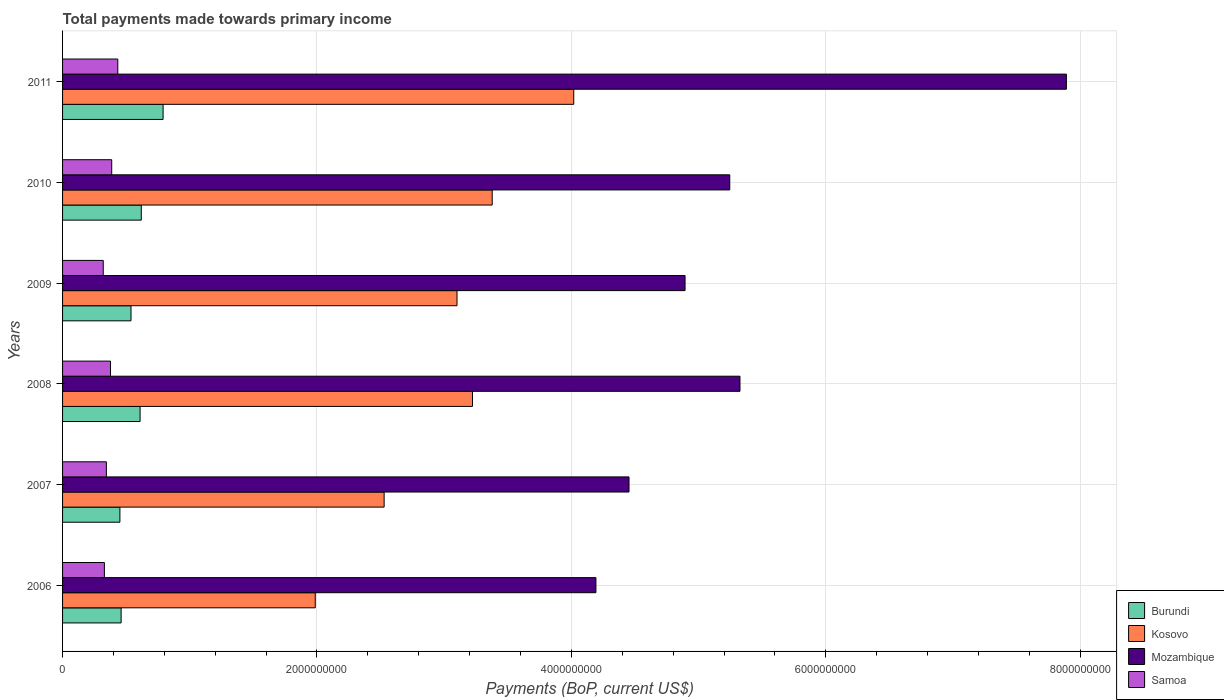How many different coloured bars are there?
Your response must be concise. 4. How many bars are there on the 2nd tick from the top?
Keep it short and to the point. 4. How many bars are there on the 6th tick from the bottom?
Offer a very short reply. 4. What is the total payments made towards primary income in Kosovo in 2009?
Your response must be concise. 3.10e+09. Across all years, what is the maximum total payments made towards primary income in Mozambique?
Provide a succinct answer. 7.89e+09. Across all years, what is the minimum total payments made towards primary income in Burundi?
Your answer should be very brief. 4.51e+08. In which year was the total payments made towards primary income in Samoa maximum?
Ensure brevity in your answer.  2011. What is the total total payments made towards primary income in Mozambique in the graph?
Offer a terse response. 3.20e+1. What is the difference between the total payments made towards primary income in Samoa in 2009 and that in 2011?
Provide a short and direct response. -1.14e+08. What is the difference between the total payments made towards primary income in Kosovo in 2006 and the total payments made towards primary income in Samoa in 2007?
Make the answer very short. 1.64e+09. What is the average total payments made towards primary income in Burundi per year?
Provide a succinct answer. 5.78e+08. In the year 2010, what is the difference between the total payments made towards primary income in Samoa and total payments made towards primary income in Burundi?
Provide a succinct answer. -2.32e+08. What is the ratio of the total payments made towards primary income in Mozambique in 2006 to that in 2011?
Give a very brief answer. 0.53. Is the total payments made towards primary income in Kosovo in 2006 less than that in 2011?
Keep it short and to the point. Yes. What is the difference between the highest and the second highest total payments made towards primary income in Samoa?
Your answer should be compact. 4.78e+07. What is the difference between the highest and the lowest total payments made towards primary income in Kosovo?
Your response must be concise. 2.03e+09. In how many years, is the total payments made towards primary income in Burundi greater than the average total payments made towards primary income in Burundi taken over all years?
Your response must be concise. 3. Is the sum of the total payments made towards primary income in Mozambique in 2007 and 2009 greater than the maximum total payments made towards primary income in Samoa across all years?
Your answer should be very brief. Yes. Is it the case that in every year, the sum of the total payments made towards primary income in Samoa and total payments made towards primary income in Burundi is greater than the sum of total payments made towards primary income in Mozambique and total payments made towards primary income in Kosovo?
Your answer should be compact. No. What does the 1st bar from the top in 2006 represents?
Make the answer very short. Samoa. What does the 3rd bar from the bottom in 2010 represents?
Offer a terse response. Mozambique. Are the values on the major ticks of X-axis written in scientific E-notation?
Provide a short and direct response. No. Where does the legend appear in the graph?
Ensure brevity in your answer.  Bottom right. How are the legend labels stacked?
Your response must be concise. Vertical. What is the title of the graph?
Your response must be concise. Total payments made towards primary income. What is the label or title of the X-axis?
Your response must be concise. Payments (BoP, current US$). What is the Payments (BoP, current US$) in Burundi in 2006?
Make the answer very short. 4.60e+08. What is the Payments (BoP, current US$) of Kosovo in 2006?
Your answer should be compact. 1.99e+09. What is the Payments (BoP, current US$) in Mozambique in 2006?
Make the answer very short. 4.19e+09. What is the Payments (BoP, current US$) in Samoa in 2006?
Offer a very short reply. 3.29e+08. What is the Payments (BoP, current US$) of Burundi in 2007?
Offer a terse response. 4.51e+08. What is the Payments (BoP, current US$) in Kosovo in 2007?
Offer a very short reply. 2.53e+09. What is the Payments (BoP, current US$) in Mozambique in 2007?
Your answer should be compact. 4.45e+09. What is the Payments (BoP, current US$) of Samoa in 2007?
Make the answer very short. 3.44e+08. What is the Payments (BoP, current US$) of Burundi in 2008?
Provide a short and direct response. 6.09e+08. What is the Payments (BoP, current US$) of Kosovo in 2008?
Make the answer very short. 3.22e+09. What is the Payments (BoP, current US$) in Mozambique in 2008?
Keep it short and to the point. 5.33e+09. What is the Payments (BoP, current US$) in Samoa in 2008?
Make the answer very short. 3.77e+08. What is the Payments (BoP, current US$) in Burundi in 2009?
Your answer should be very brief. 5.38e+08. What is the Payments (BoP, current US$) in Kosovo in 2009?
Provide a succinct answer. 3.10e+09. What is the Payments (BoP, current US$) in Mozambique in 2009?
Provide a succinct answer. 4.89e+09. What is the Payments (BoP, current US$) of Samoa in 2009?
Keep it short and to the point. 3.20e+08. What is the Payments (BoP, current US$) of Burundi in 2010?
Make the answer very short. 6.19e+08. What is the Payments (BoP, current US$) in Kosovo in 2010?
Provide a short and direct response. 3.38e+09. What is the Payments (BoP, current US$) in Mozambique in 2010?
Ensure brevity in your answer.  5.24e+09. What is the Payments (BoP, current US$) in Samoa in 2010?
Offer a terse response. 3.86e+08. What is the Payments (BoP, current US$) of Burundi in 2011?
Your answer should be very brief. 7.90e+08. What is the Payments (BoP, current US$) in Kosovo in 2011?
Ensure brevity in your answer.  4.02e+09. What is the Payments (BoP, current US$) of Mozambique in 2011?
Your response must be concise. 7.89e+09. What is the Payments (BoP, current US$) of Samoa in 2011?
Your response must be concise. 4.34e+08. Across all years, what is the maximum Payments (BoP, current US$) in Burundi?
Provide a short and direct response. 7.90e+08. Across all years, what is the maximum Payments (BoP, current US$) of Kosovo?
Provide a short and direct response. 4.02e+09. Across all years, what is the maximum Payments (BoP, current US$) in Mozambique?
Make the answer very short. 7.89e+09. Across all years, what is the maximum Payments (BoP, current US$) of Samoa?
Your answer should be compact. 4.34e+08. Across all years, what is the minimum Payments (BoP, current US$) of Burundi?
Keep it short and to the point. 4.51e+08. Across all years, what is the minimum Payments (BoP, current US$) in Kosovo?
Ensure brevity in your answer.  1.99e+09. Across all years, what is the minimum Payments (BoP, current US$) in Mozambique?
Make the answer very short. 4.19e+09. Across all years, what is the minimum Payments (BoP, current US$) in Samoa?
Make the answer very short. 3.20e+08. What is the total Payments (BoP, current US$) of Burundi in the graph?
Offer a very short reply. 3.47e+09. What is the total Payments (BoP, current US$) in Kosovo in the graph?
Ensure brevity in your answer.  1.82e+1. What is the total Payments (BoP, current US$) of Mozambique in the graph?
Ensure brevity in your answer.  3.20e+1. What is the total Payments (BoP, current US$) in Samoa in the graph?
Your answer should be compact. 2.19e+09. What is the difference between the Payments (BoP, current US$) in Burundi in 2006 and that in 2007?
Offer a terse response. 9.56e+06. What is the difference between the Payments (BoP, current US$) of Kosovo in 2006 and that in 2007?
Your response must be concise. -5.41e+08. What is the difference between the Payments (BoP, current US$) in Mozambique in 2006 and that in 2007?
Offer a very short reply. -2.60e+08. What is the difference between the Payments (BoP, current US$) of Samoa in 2006 and that in 2007?
Keep it short and to the point. -1.56e+07. What is the difference between the Payments (BoP, current US$) in Burundi in 2006 and that in 2008?
Your response must be concise. -1.49e+08. What is the difference between the Payments (BoP, current US$) in Kosovo in 2006 and that in 2008?
Your response must be concise. -1.24e+09. What is the difference between the Payments (BoP, current US$) of Mozambique in 2006 and that in 2008?
Your response must be concise. -1.13e+09. What is the difference between the Payments (BoP, current US$) of Samoa in 2006 and that in 2008?
Offer a terse response. -4.81e+07. What is the difference between the Payments (BoP, current US$) in Burundi in 2006 and that in 2009?
Keep it short and to the point. -7.76e+07. What is the difference between the Payments (BoP, current US$) in Kosovo in 2006 and that in 2009?
Make the answer very short. -1.11e+09. What is the difference between the Payments (BoP, current US$) in Mozambique in 2006 and that in 2009?
Your answer should be very brief. -7.01e+08. What is the difference between the Payments (BoP, current US$) of Samoa in 2006 and that in 2009?
Offer a terse response. 8.97e+06. What is the difference between the Payments (BoP, current US$) of Burundi in 2006 and that in 2010?
Make the answer very short. -1.58e+08. What is the difference between the Payments (BoP, current US$) of Kosovo in 2006 and that in 2010?
Your response must be concise. -1.39e+09. What is the difference between the Payments (BoP, current US$) in Mozambique in 2006 and that in 2010?
Offer a very short reply. -1.05e+09. What is the difference between the Payments (BoP, current US$) in Samoa in 2006 and that in 2010?
Give a very brief answer. -5.76e+07. What is the difference between the Payments (BoP, current US$) in Burundi in 2006 and that in 2011?
Make the answer very short. -3.30e+08. What is the difference between the Payments (BoP, current US$) in Kosovo in 2006 and that in 2011?
Provide a succinct answer. -2.03e+09. What is the difference between the Payments (BoP, current US$) in Mozambique in 2006 and that in 2011?
Offer a terse response. -3.70e+09. What is the difference between the Payments (BoP, current US$) of Samoa in 2006 and that in 2011?
Your answer should be compact. -1.05e+08. What is the difference between the Payments (BoP, current US$) of Burundi in 2007 and that in 2008?
Offer a terse response. -1.59e+08. What is the difference between the Payments (BoP, current US$) in Kosovo in 2007 and that in 2008?
Offer a very short reply. -6.94e+08. What is the difference between the Payments (BoP, current US$) of Mozambique in 2007 and that in 2008?
Offer a terse response. -8.72e+08. What is the difference between the Payments (BoP, current US$) of Samoa in 2007 and that in 2008?
Your answer should be compact. -3.25e+07. What is the difference between the Payments (BoP, current US$) in Burundi in 2007 and that in 2009?
Provide a succinct answer. -8.72e+07. What is the difference between the Payments (BoP, current US$) of Kosovo in 2007 and that in 2009?
Your answer should be very brief. -5.73e+08. What is the difference between the Payments (BoP, current US$) of Mozambique in 2007 and that in 2009?
Keep it short and to the point. -4.41e+08. What is the difference between the Payments (BoP, current US$) in Samoa in 2007 and that in 2009?
Provide a succinct answer. 2.46e+07. What is the difference between the Payments (BoP, current US$) in Burundi in 2007 and that in 2010?
Your response must be concise. -1.68e+08. What is the difference between the Payments (BoP, current US$) of Kosovo in 2007 and that in 2010?
Make the answer very short. -8.50e+08. What is the difference between the Payments (BoP, current US$) of Mozambique in 2007 and that in 2010?
Your answer should be very brief. -7.92e+08. What is the difference between the Payments (BoP, current US$) of Samoa in 2007 and that in 2010?
Ensure brevity in your answer.  -4.20e+07. What is the difference between the Payments (BoP, current US$) in Burundi in 2007 and that in 2011?
Your answer should be compact. -3.39e+08. What is the difference between the Payments (BoP, current US$) of Kosovo in 2007 and that in 2011?
Your response must be concise. -1.49e+09. What is the difference between the Payments (BoP, current US$) of Mozambique in 2007 and that in 2011?
Provide a short and direct response. -3.44e+09. What is the difference between the Payments (BoP, current US$) in Samoa in 2007 and that in 2011?
Ensure brevity in your answer.  -8.98e+07. What is the difference between the Payments (BoP, current US$) of Burundi in 2008 and that in 2009?
Provide a short and direct response. 7.14e+07. What is the difference between the Payments (BoP, current US$) of Kosovo in 2008 and that in 2009?
Offer a very short reply. 1.22e+08. What is the difference between the Payments (BoP, current US$) in Mozambique in 2008 and that in 2009?
Keep it short and to the point. 4.32e+08. What is the difference between the Payments (BoP, current US$) in Samoa in 2008 and that in 2009?
Your response must be concise. 5.70e+07. What is the difference between the Payments (BoP, current US$) of Burundi in 2008 and that in 2010?
Your answer should be very brief. -9.31e+06. What is the difference between the Payments (BoP, current US$) of Kosovo in 2008 and that in 2010?
Make the answer very short. -1.55e+08. What is the difference between the Payments (BoP, current US$) in Mozambique in 2008 and that in 2010?
Provide a short and direct response. 8.03e+07. What is the difference between the Payments (BoP, current US$) of Samoa in 2008 and that in 2010?
Offer a very short reply. -9.55e+06. What is the difference between the Payments (BoP, current US$) of Burundi in 2008 and that in 2011?
Your answer should be compact. -1.81e+08. What is the difference between the Payments (BoP, current US$) in Kosovo in 2008 and that in 2011?
Ensure brevity in your answer.  -7.96e+08. What is the difference between the Payments (BoP, current US$) in Mozambique in 2008 and that in 2011?
Your response must be concise. -2.57e+09. What is the difference between the Payments (BoP, current US$) in Samoa in 2008 and that in 2011?
Your response must be concise. -5.74e+07. What is the difference between the Payments (BoP, current US$) in Burundi in 2009 and that in 2010?
Offer a very short reply. -8.07e+07. What is the difference between the Payments (BoP, current US$) of Kosovo in 2009 and that in 2010?
Provide a succinct answer. -2.77e+08. What is the difference between the Payments (BoP, current US$) in Mozambique in 2009 and that in 2010?
Make the answer very short. -3.51e+08. What is the difference between the Payments (BoP, current US$) in Samoa in 2009 and that in 2010?
Provide a succinct answer. -6.66e+07. What is the difference between the Payments (BoP, current US$) of Burundi in 2009 and that in 2011?
Your response must be concise. -2.52e+08. What is the difference between the Payments (BoP, current US$) in Kosovo in 2009 and that in 2011?
Offer a very short reply. -9.18e+08. What is the difference between the Payments (BoP, current US$) of Mozambique in 2009 and that in 2011?
Your answer should be very brief. -3.00e+09. What is the difference between the Payments (BoP, current US$) in Samoa in 2009 and that in 2011?
Your answer should be compact. -1.14e+08. What is the difference between the Payments (BoP, current US$) in Burundi in 2010 and that in 2011?
Keep it short and to the point. -1.72e+08. What is the difference between the Payments (BoP, current US$) of Kosovo in 2010 and that in 2011?
Provide a succinct answer. -6.41e+08. What is the difference between the Payments (BoP, current US$) in Mozambique in 2010 and that in 2011?
Keep it short and to the point. -2.65e+09. What is the difference between the Payments (BoP, current US$) in Samoa in 2010 and that in 2011?
Offer a terse response. -4.78e+07. What is the difference between the Payments (BoP, current US$) in Burundi in 2006 and the Payments (BoP, current US$) in Kosovo in 2007?
Ensure brevity in your answer.  -2.07e+09. What is the difference between the Payments (BoP, current US$) in Burundi in 2006 and the Payments (BoP, current US$) in Mozambique in 2007?
Your answer should be compact. -3.99e+09. What is the difference between the Payments (BoP, current US$) of Burundi in 2006 and the Payments (BoP, current US$) of Samoa in 2007?
Provide a short and direct response. 1.16e+08. What is the difference between the Payments (BoP, current US$) in Kosovo in 2006 and the Payments (BoP, current US$) in Mozambique in 2007?
Give a very brief answer. -2.47e+09. What is the difference between the Payments (BoP, current US$) of Kosovo in 2006 and the Payments (BoP, current US$) of Samoa in 2007?
Make the answer very short. 1.64e+09. What is the difference between the Payments (BoP, current US$) of Mozambique in 2006 and the Payments (BoP, current US$) of Samoa in 2007?
Provide a succinct answer. 3.85e+09. What is the difference between the Payments (BoP, current US$) of Burundi in 2006 and the Payments (BoP, current US$) of Kosovo in 2008?
Provide a succinct answer. -2.76e+09. What is the difference between the Payments (BoP, current US$) in Burundi in 2006 and the Payments (BoP, current US$) in Mozambique in 2008?
Your answer should be very brief. -4.86e+09. What is the difference between the Payments (BoP, current US$) of Burundi in 2006 and the Payments (BoP, current US$) of Samoa in 2008?
Make the answer very short. 8.35e+07. What is the difference between the Payments (BoP, current US$) in Kosovo in 2006 and the Payments (BoP, current US$) in Mozambique in 2008?
Provide a succinct answer. -3.34e+09. What is the difference between the Payments (BoP, current US$) of Kosovo in 2006 and the Payments (BoP, current US$) of Samoa in 2008?
Keep it short and to the point. 1.61e+09. What is the difference between the Payments (BoP, current US$) of Mozambique in 2006 and the Payments (BoP, current US$) of Samoa in 2008?
Give a very brief answer. 3.82e+09. What is the difference between the Payments (BoP, current US$) in Burundi in 2006 and the Payments (BoP, current US$) in Kosovo in 2009?
Provide a short and direct response. -2.64e+09. What is the difference between the Payments (BoP, current US$) in Burundi in 2006 and the Payments (BoP, current US$) in Mozambique in 2009?
Give a very brief answer. -4.43e+09. What is the difference between the Payments (BoP, current US$) in Burundi in 2006 and the Payments (BoP, current US$) in Samoa in 2009?
Make the answer very short. 1.41e+08. What is the difference between the Payments (BoP, current US$) of Kosovo in 2006 and the Payments (BoP, current US$) of Mozambique in 2009?
Give a very brief answer. -2.91e+09. What is the difference between the Payments (BoP, current US$) in Kosovo in 2006 and the Payments (BoP, current US$) in Samoa in 2009?
Your response must be concise. 1.67e+09. What is the difference between the Payments (BoP, current US$) in Mozambique in 2006 and the Payments (BoP, current US$) in Samoa in 2009?
Provide a succinct answer. 3.87e+09. What is the difference between the Payments (BoP, current US$) of Burundi in 2006 and the Payments (BoP, current US$) of Kosovo in 2010?
Provide a short and direct response. -2.92e+09. What is the difference between the Payments (BoP, current US$) in Burundi in 2006 and the Payments (BoP, current US$) in Mozambique in 2010?
Your answer should be very brief. -4.78e+09. What is the difference between the Payments (BoP, current US$) of Burundi in 2006 and the Payments (BoP, current US$) of Samoa in 2010?
Provide a short and direct response. 7.40e+07. What is the difference between the Payments (BoP, current US$) of Kosovo in 2006 and the Payments (BoP, current US$) of Mozambique in 2010?
Ensure brevity in your answer.  -3.26e+09. What is the difference between the Payments (BoP, current US$) of Kosovo in 2006 and the Payments (BoP, current US$) of Samoa in 2010?
Give a very brief answer. 1.60e+09. What is the difference between the Payments (BoP, current US$) of Mozambique in 2006 and the Payments (BoP, current US$) of Samoa in 2010?
Give a very brief answer. 3.81e+09. What is the difference between the Payments (BoP, current US$) of Burundi in 2006 and the Payments (BoP, current US$) of Kosovo in 2011?
Provide a short and direct response. -3.56e+09. What is the difference between the Payments (BoP, current US$) of Burundi in 2006 and the Payments (BoP, current US$) of Mozambique in 2011?
Provide a succinct answer. -7.43e+09. What is the difference between the Payments (BoP, current US$) of Burundi in 2006 and the Payments (BoP, current US$) of Samoa in 2011?
Offer a very short reply. 2.62e+07. What is the difference between the Payments (BoP, current US$) in Kosovo in 2006 and the Payments (BoP, current US$) in Mozambique in 2011?
Provide a succinct answer. -5.90e+09. What is the difference between the Payments (BoP, current US$) in Kosovo in 2006 and the Payments (BoP, current US$) in Samoa in 2011?
Keep it short and to the point. 1.55e+09. What is the difference between the Payments (BoP, current US$) of Mozambique in 2006 and the Payments (BoP, current US$) of Samoa in 2011?
Your answer should be compact. 3.76e+09. What is the difference between the Payments (BoP, current US$) in Burundi in 2007 and the Payments (BoP, current US$) in Kosovo in 2008?
Your response must be concise. -2.77e+09. What is the difference between the Payments (BoP, current US$) in Burundi in 2007 and the Payments (BoP, current US$) in Mozambique in 2008?
Give a very brief answer. -4.87e+09. What is the difference between the Payments (BoP, current US$) of Burundi in 2007 and the Payments (BoP, current US$) of Samoa in 2008?
Provide a short and direct response. 7.40e+07. What is the difference between the Payments (BoP, current US$) in Kosovo in 2007 and the Payments (BoP, current US$) in Mozambique in 2008?
Offer a very short reply. -2.80e+09. What is the difference between the Payments (BoP, current US$) in Kosovo in 2007 and the Payments (BoP, current US$) in Samoa in 2008?
Make the answer very short. 2.15e+09. What is the difference between the Payments (BoP, current US$) in Mozambique in 2007 and the Payments (BoP, current US$) in Samoa in 2008?
Provide a succinct answer. 4.08e+09. What is the difference between the Payments (BoP, current US$) in Burundi in 2007 and the Payments (BoP, current US$) in Kosovo in 2009?
Keep it short and to the point. -2.65e+09. What is the difference between the Payments (BoP, current US$) of Burundi in 2007 and the Payments (BoP, current US$) of Mozambique in 2009?
Keep it short and to the point. -4.44e+09. What is the difference between the Payments (BoP, current US$) of Burundi in 2007 and the Payments (BoP, current US$) of Samoa in 2009?
Provide a succinct answer. 1.31e+08. What is the difference between the Payments (BoP, current US$) in Kosovo in 2007 and the Payments (BoP, current US$) in Mozambique in 2009?
Your response must be concise. -2.37e+09. What is the difference between the Payments (BoP, current US$) in Kosovo in 2007 and the Payments (BoP, current US$) in Samoa in 2009?
Provide a short and direct response. 2.21e+09. What is the difference between the Payments (BoP, current US$) in Mozambique in 2007 and the Payments (BoP, current US$) in Samoa in 2009?
Give a very brief answer. 4.13e+09. What is the difference between the Payments (BoP, current US$) in Burundi in 2007 and the Payments (BoP, current US$) in Kosovo in 2010?
Your answer should be very brief. -2.93e+09. What is the difference between the Payments (BoP, current US$) of Burundi in 2007 and the Payments (BoP, current US$) of Mozambique in 2010?
Your answer should be compact. -4.79e+09. What is the difference between the Payments (BoP, current US$) of Burundi in 2007 and the Payments (BoP, current US$) of Samoa in 2010?
Provide a short and direct response. 6.44e+07. What is the difference between the Payments (BoP, current US$) of Kosovo in 2007 and the Payments (BoP, current US$) of Mozambique in 2010?
Your response must be concise. -2.72e+09. What is the difference between the Payments (BoP, current US$) in Kosovo in 2007 and the Payments (BoP, current US$) in Samoa in 2010?
Your response must be concise. 2.14e+09. What is the difference between the Payments (BoP, current US$) in Mozambique in 2007 and the Payments (BoP, current US$) in Samoa in 2010?
Ensure brevity in your answer.  4.07e+09. What is the difference between the Payments (BoP, current US$) of Burundi in 2007 and the Payments (BoP, current US$) of Kosovo in 2011?
Make the answer very short. -3.57e+09. What is the difference between the Payments (BoP, current US$) in Burundi in 2007 and the Payments (BoP, current US$) in Mozambique in 2011?
Ensure brevity in your answer.  -7.44e+09. What is the difference between the Payments (BoP, current US$) in Burundi in 2007 and the Payments (BoP, current US$) in Samoa in 2011?
Provide a succinct answer. 1.66e+07. What is the difference between the Payments (BoP, current US$) in Kosovo in 2007 and the Payments (BoP, current US$) in Mozambique in 2011?
Offer a very short reply. -5.36e+09. What is the difference between the Payments (BoP, current US$) of Kosovo in 2007 and the Payments (BoP, current US$) of Samoa in 2011?
Your answer should be very brief. 2.09e+09. What is the difference between the Payments (BoP, current US$) in Mozambique in 2007 and the Payments (BoP, current US$) in Samoa in 2011?
Your answer should be very brief. 4.02e+09. What is the difference between the Payments (BoP, current US$) in Burundi in 2008 and the Payments (BoP, current US$) in Kosovo in 2009?
Your answer should be very brief. -2.49e+09. What is the difference between the Payments (BoP, current US$) of Burundi in 2008 and the Payments (BoP, current US$) of Mozambique in 2009?
Offer a very short reply. -4.28e+09. What is the difference between the Payments (BoP, current US$) in Burundi in 2008 and the Payments (BoP, current US$) in Samoa in 2009?
Your response must be concise. 2.90e+08. What is the difference between the Payments (BoP, current US$) of Kosovo in 2008 and the Payments (BoP, current US$) of Mozambique in 2009?
Give a very brief answer. -1.67e+09. What is the difference between the Payments (BoP, current US$) of Kosovo in 2008 and the Payments (BoP, current US$) of Samoa in 2009?
Offer a very short reply. 2.90e+09. What is the difference between the Payments (BoP, current US$) in Mozambique in 2008 and the Payments (BoP, current US$) in Samoa in 2009?
Give a very brief answer. 5.01e+09. What is the difference between the Payments (BoP, current US$) of Burundi in 2008 and the Payments (BoP, current US$) of Kosovo in 2010?
Your answer should be compact. -2.77e+09. What is the difference between the Payments (BoP, current US$) of Burundi in 2008 and the Payments (BoP, current US$) of Mozambique in 2010?
Make the answer very short. -4.64e+09. What is the difference between the Payments (BoP, current US$) of Burundi in 2008 and the Payments (BoP, current US$) of Samoa in 2010?
Make the answer very short. 2.23e+08. What is the difference between the Payments (BoP, current US$) in Kosovo in 2008 and the Payments (BoP, current US$) in Mozambique in 2010?
Offer a terse response. -2.02e+09. What is the difference between the Payments (BoP, current US$) in Kosovo in 2008 and the Payments (BoP, current US$) in Samoa in 2010?
Ensure brevity in your answer.  2.84e+09. What is the difference between the Payments (BoP, current US$) in Mozambique in 2008 and the Payments (BoP, current US$) in Samoa in 2010?
Offer a terse response. 4.94e+09. What is the difference between the Payments (BoP, current US$) in Burundi in 2008 and the Payments (BoP, current US$) in Kosovo in 2011?
Offer a very short reply. -3.41e+09. What is the difference between the Payments (BoP, current US$) of Burundi in 2008 and the Payments (BoP, current US$) of Mozambique in 2011?
Give a very brief answer. -7.28e+09. What is the difference between the Payments (BoP, current US$) of Burundi in 2008 and the Payments (BoP, current US$) of Samoa in 2011?
Offer a terse response. 1.75e+08. What is the difference between the Payments (BoP, current US$) in Kosovo in 2008 and the Payments (BoP, current US$) in Mozambique in 2011?
Offer a very short reply. -4.67e+09. What is the difference between the Payments (BoP, current US$) in Kosovo in 2008 and the Payments (BoP, current US$) in Samoa in 2011?
Offer a very short reply. 2.79e+09. What is the difference between the Payments (BoP, current US$) in Mozambique in 2008 and the Payments (BoP, current US$) in Samoa in 2011?
Provide a short and direct response. 4.89e+09. What is the difference between the Payments (BoP, current US$) in Burundi in 2009 and the Payments (BoP, current US$) in Kosovo in 2010?
Your answer should be very brief. -2.84e+09. What is the difference between the Payments (BoP, current US$) in Burundi in 2009 and the Payments (BoP, current US$) in Mozambique in 2010?
Make the answer very short. -4.71e+09. What is the difference between the Payments (BoP, current US$) of Burundi in 2009 and the Payments (BoP, current US$) of Samoa in 2010?
Provide a short and direct response. 1.52e+08. What is the difference between the Payments (BoP, current US$) in Kosovo in 2009 and the Payments (BoP, current US$) in Mozambique in 2010?
Make the answer very short. -2.14e+09. What is the difference between the Payments (BoP, current US$) in Kosovo in 2009 and the Payments (BoP, current US$) in Samoa in 2010?
Ensure brevity in your answer.  2.71e+09. What is the difference between the Payments (BoP, current US$) in Mozambique in 2009 and the Payments (BoP, current US$) in Samoa in 2010?
Provide a succinct answer. 4.51e+09. What is the difference between the Payments (BoP, current US$) in Burundi in 2009 and the Payments (BoP, current US$) in Kosovo in 2011?
Keep it short and to the point. -3.48e+09. What is the difference between the Payments (BoP, current US$) in Burundi in 2009 and the Payments (BoP, current US$) in Mozambique in 2011?
Give a very brief answer. -7.35e+09. What is the difference between the Payments (BoP, current US$) in Burundi in 2009 and the Payments (BoP, current US$) in Samoa in 2011?
Your response must be concise. 1.04e+08. What is the difference between the Payments (BoP, current US$) in Kosovo in 2009 and the Payments (BoP, current US$) in Mozambique in 2011?
Your answer should be compact. -4.79e+09. What is the difference between the Payments (BoP, current US$) in Kosovo in 2009 and the Payments (BoP, current US$) in Samoa in 2011?
Provide a succinct answer. 2.67e+09. What is the difference between the Payments (BoP, current US$) in Mozambique in 2009 and the Payments (BoP, current US$) in Samoa in 2011?
Your answer should be compact. 4.46e+09. What is the difference between the Payments (BoP, current US$) in Burundi in 2010 and the Payments (BoP, current US$) in Kosovo in 2011?
Ensure brevity in your answer.  -3.40e+09. What is the difference between the Payments (BoP, current US$) of Burundi in 2010 and the Payments (BoP, current US$) of Mozambique in 2011?
Your answer should be very brief. -7.27e+09. What is the difference between the Payments (BoP, current US$) of Burundi in 2010 and the Payments (BoP, current US$) of Samoa in 2011?
Offer a terse response. 1.85e+08. What is the difference between the Payments (BoP, current US$) in Kosovo in 2010 and the Payments (BoP, current US$) in Mozambique in 2011?
Your response must be concise. -4.51e+09. What is the difference between the Payments (BoP, current US$) in Kosovo in 2010 and the Payments (BoP, current US$) in Samoa in 2011?
Offer a terse response. 2.94e+09. What is the difference between the Payments (BoP, current US$) in Mozambique in 2010 and the Payments (BoP, current US$) in Samoa in 2011?
Your answer should be compact. 4.81e+09. What is the average Payments (BoP, current US$) of Burundi per year?
Make the answer very short. 5.78e+08. What is the average Payments (BoP, current US$) in Kosovo per year?
Offer a very short reply. 3.04e+09. What is the average Payments (BoP, current US$) in Mozambique per year?
Offer a very short reply. 5.33e+09. What is the average Payments (BoP, current US$) in Samoa per year?
Make the answer very short. 3.65e+08. In the year 2006, what is the difference between the Payments (BoP, current US$) in Burundi and Payments (BoP, current US$) in Kosovo?
Your response must be concise. -1.53e+09. In the year 2006, what is the difference between the Payments (BoP, current US$) in Burundi and Payments (BoP, current US$) in Mozambique?
Give a very brief answer. -3.73e+09. In the year 2006, what is the difference between the Payments (BoP, current US$) of Burundi and Payments (BoP, current US$) of Samoa?
Offer a very short reply. 1.32e+08. In the year 2006, what is the difference between the Payments (BoP, current US$) in Kosovo and Payments (BoP, current US$) in Mozambique?
Your answer should be compact. -2.21e+09. In the year 2006, what is the difference between the Payments (BoP, current US$) in Kosovo and Payments (BoP, current US$) in Samoa?
Your answer should be compact. 1.66e+09. In the year 2006, what is the difference between the Payments (BoP, current US$) of Mozambique and Payments (BoP, current US$) of Samoa?
Keep it short and to the point. 3.86e+09. In the year 2007, what is the difference between the Payments (BoP, current US$) of Burundi and Payments (BoP, current US$) of Kosovo?
Ensure brevity in your answer.  -2.08e+09. In the year 2007, what is the difference between the Payments (BoP, current US$) of Burundi and Payments (BoP, current US$) of Mozambique?
Offer a terse response. -4.00e+09. In the year 2007, what is the difference between the Payments (BoP, current US$) in Burundi and Payments (BoP, current US$) in Samoa?
Offer a terse response. 1.06e+08. In the year 2007, what is the difference between the Payments (BoP, current US$) in Kosovo and Payments (BoP, current US$) in Mozambique?
Offer a terse response. -1.92e+09. In the year 2007, what is the difference between the Payments (BoP, current US$) in Kosovo and Payments (BoP, current US$) in Samoa?
Make the answer very short. 2.18e+09. In the year 2007, what is the difference between the Payments (BoP, current US$) in Mozambique and Payments (BoP, current US$) in Samoa?
Provide a succinct answer. 4.11e+09. In the year 2008, what is the difference between the Payments (BoP, current US$) in Burundi and Payments (BoP, current US$) in Kosovo?
Offer a terse response. -2.61e+09. In the year 2008, what is the difference between the Payments (BoP, current US$) in Burundi and Payments (BoP, current US$) in Mozambique?
Your response must be concise. -4.72e+09. In the year 2008, what is the difference between the Payments (BoP, current US$) of Burundi and Payments (BoP, current US$) of Samoa?
Your response must be concise. 2.33e+08. In the year 2008, what is the difference between the Payments (BoP, current US$) of Kosovo and Payments (BoP, current US$) of Mozambique?
Keep it short and to the point. -2.10e+09. In the year 2008, what is the difference between the Payments (BoP, current US$) in Kosovo and Payments (BoP, current US$) in Samoa?
Provide a short and direct response. 2.85e+09. In the year 2008, what is the difference between the Payments (BoP, current US$) in Mozambique and Payments (BoP, current US$) in Samoa?
Ensure brevity in your answer.  4.95e+09. In the year 2009, what is the difference between the Payments (BoP, current US$) of Burundi and Payments (BoP, current US$) of Kosovo?
Give a very brief answer. -2.56e+09. In the year 2009, what is the difference between the Payments (BoP, current US$) of Burundi and Payments (BoP, current US$) of Mozambique?
Keep it short and to the point. -4.36e+09. In the year 2009, what is the difference between the Payments (BoP, current US$) of Burundi and Payments (BoP, current US$) of Samoa?
Provide a succinct answer. 2.18e+08. In the year 2009, what is the difference between the Payments (BoP, current US$) of Kosovo and Payments (BoP, current US$) of Mozambique?
Your answer should be compact. -1.79e+09. In the year 2009, what is the difference between the Payments (BoP, current US$) in Kosovo and Payments (BoP, current US$) in Samoa?
Your response must be concise. 2.78e+09. In the year 2009, what is the difference between the Payments (BoP, current US$) of Mozambique and Payments (BoP, current US$) of Samoa?
Keep it short and to the point. 4.57e+09. In the year 2010, what is the difference between the Payments (BoP, current US$) in Burundi and Payments (BoP, current US$) in Kosovo?
Offer a terse response. -2.76e+09. In the year 2010, what is the difference between the Payments (BoP, current US$) of Burundi and Payments (BoP, current US$) of Mozambique?
Make the answer very short. -4.63e+09. In the year 2010, what is the difference between the Payments (BoP, current US$) in Burundi and Payments (BoP, current US$) in Samoa?
Your answer should be very brief. 2.32e+08. In the year 2010, what is the difference between the Payments (BoP, current US$) of Kosovo and Payments (BoP, current US$) of Mozambique?
Your response must be concise. -1.87e+09. In the year 2010, what is the difference between the Payments (BoP, current US$) in Kosovo and Payments (BoP, current US$) in Samoa?
Offer a very short reply. 2.99e+09. In the year 2010, what is the difference between the Payments (BoP, current US$) of Mozambique and Payments (BoP, current US$) of Samoa?
Provide a short and direct response. 4.86e+09. In the year 2011, what is the difference between the Payments (BoP, current US$) of Burundi and Payments (BoP, current US$) of Kosovo?
Offer a very short reply. -3.23e+09. In the year 2011, what is the difference between the Payments (BoP, current US$) of Burundi and Payments (BoP, current US$) of Mozambique?
Offer a terse response. -7.10e+09. In the year 2011, what is the difference between the Payments (BoP, current US$) of Burundi and Payments (BoP, current US$) of Samoa?
Provide a short and direct response. 3.56e+08. In the year 2011, what is the difference between the Payments (BoP, current US$) of Kosovo and Payments (BoP, current US$) of Mozambique?
Offer a very short reply. -3.87e+09. In the year 2011, what is the difference between the Payments (BoP, current US$) in Kosovo and Payments (BoP, current US$) in Samoa?
Offer a terse response. 3.58e+09. In the year 2011, what is the difference between the Payments (BoP, current US$) of Mozambique and Payments (BoP, current US$) of Samoa?
Offer a very short reply. 7.46e+09. What is the ratio of the Payments (BoP, current US$) in Burundi in 2006 to that in 2007?
Your response must be concise. 1.02. What is the ratio of the Payments (BoP, current US$) in Kosovo in 2006 to that in 2007?
Keep it short and to the point. 0.79. What is the ratio of the Payments (BoP, current US$) of Mozambique in 2006 to that in 2007?
Offer a very short reply. 0.94. What is the ratio of the Payments (BoP, current US$) in Samoa in 2006 to that in 2007?
Your response must be concise. 0.95. What is the ratio of the Payments (BoP, current US$) of Burundi in 2006 to that in 2008?
Give a very brief answer. 0.76. What is the ratio of the Payments (BoP, current US$) of Kosovo in 2006 to that in 2008?
Offer a very short reply. 0.62. What is the ratio of the Payments (BoP, current US$) in Mozambique in 2006 to that in 2008?
Your answer should be very brief. 0.79. What is the ratio of the Payments (BoP, current US$) of Samoa in 2006 to that in 2008?
Your answer should be compact. 0.87. What is the ratio of the Payments (BoP, current US$) of Burundi in 2006 to that in 2009?
Your answer should be very brief. 0.86. What is the ratio of the Payments (BoP, current US$) of Kosovo in 2006 to that in 2009?
Your response must be concise. 0.64. What is the ratio of the Payments (BoP, current US$) in Mozambique in 2006 to that in 2009?
Offer a very short reply. 0.86. What is the ratio of the Payments (BoP, current US$) of Samoa in 2006 to that in 2009?
Provide a succinct answer. 1.03. What is the ratio of the Payments (BoP, current US$) of Burundi in 2006 to that in 2010?
Ensure brevity in your answer.  0.74. What is the ratio of the Payments (BoP, current US$) of Kosovo in 2006 to that in 2010?
Make the answer very short. 0.59. What is the ratio of the Payments (BoP, current US$) in Mozambique in 2006 to that in 2010?
Offer a very short reply. 0.8. What is the ratio of the Payments (BoP, current US$) in Samoa in 2006 to that in 2010?
Your answer should be very brief. 0.85. What is the ratio of the Payments (BoP, current US$) in Burundi in 2006 to that in 2011?
Keep it short and to the point. 0.58. What is the ratio of the Payments (BoP, current US$) of Kosovo in 2006 to that in 2011?
Give a very brief answer. 0.49. What is the ratio of the Payments (BoP, current US$) in Mozambique in 2006 to that in 2011?
Your answer should be compact. 0.53. What is the ratio of the Payments (BoP, current US$) in Samoa in 2006 to that in 2011?
Your response must be concise. 0.76. What is the ratio of the Payments (BoP, current US$) of Burundi in 2007 to that in 2008?
Make the answer very short. 0.74. What is the ratio of the Payments (BoP, current US$) in Kosovo in 2007 to that in 2008?
Provide a succinct answer. 0.78. What is the ratio of the Payments (BoP, current US$) of Mozambique in 2007 to that in 2008?
Keep it short and to the point. 0.84. What is the ratio of the Payments (BoP, current US$) in Samoa in 2007 to that in 2008?
Keep it short and to the point. 0.91. What is the ratio of the Payments (BoP, current US$) in Burundi in 2007 to that in 2009?
Offer a terse response. 0.84. What is the ratio of the Payments (BoP, current US$) of Kosovo in 2007 to that in 2009?
Make the answer very short. 0.82. What is the ratio of the Payments (BoP, current US$) in Mozambique in 2007 to that in 2009?
Offer a terse response. 0.91. What is the ratio of the Payments (BoP, current US$) of Samoa in 2007 to that in 2009?
Provide a succinct answer. 1.08. What is the ratio of the Payments (BoP, current US$) of Burundi in 2007 to that in 2010?
Your answer should be compact. 0.73. What is the ratio of the Payments (BoP, current US$) of Kosovo in 2007 to that in 2010?
Provide a short and direct response. 0.75. What is the ratio of the Payments (BoP, current US$) of Mozambique in 2007 to that in 2010?
Offer a terse response. 0.85. What is the ratio of the Payments (BoP, current US$) in Samoa in 2007 to that in 2010?
Your answer should be very brief. 0.89. What is the ratio of the Payments (BoP, current US$) of Burundi in 2007 to that in 2011?
Offer a very short reply. 0.57. What is the ratio of the Payments (BoP, current US$) of Kosovo in 2007 to that in 2011?
Ensure brevity in your answer.  0.63. What is the ratio of the Payments (BoP, current US$) of Mozambique in 2007 to that in 2011?
Offer a terse response. 0.56. What is the ratio of the Payments (BoP, current US$) of Samoa in 2007 to that in 2011?
Make the answer very short. 0.79. What is the ratio of the Payments (BoP, current US$) in Burundi in 2008 to that in 2009?
Your answer should be very brief. 1.13. What is the ratio of the Payments (BoP, current US$) in Kosovo in 2008 to that in 2009?
Offer a very short reply. 1.04. What is the ratio of the Payments (BoP, current US$) in Mozambique in 2008 to that in 2009?
Make the answer very short. 1.09. What is the ratio of the Payments (BoP, current US$) in Samoa in 2008 to that in 2009?
Your answer should be very brief. 1.18. What is the ratio of the Payments (BoP, current US$) in Kosovo in 2008 to that in 2010?
Make the answer very short. 0.95. What is the ratio of the Payments (BoP, current US$) of Mozambique in 2008 to that in 2010?
Offer a terse response. 1.02. What is the ratio of the Payments (BoP, current US$) of Samoa in 2008 to that in 2010?
Your answer should be compact. 0.98. What is the ratio of the Payments (BoP, current US$) of Burundi in 2008 to that in 2011?
Your answer should be very brief. 0.77. What is the ratio of the Payments (BoP, current US$) in Kosovo in 2008 to that in 2011?
Ensure brevity in your answer.  0.8. What is the ratio of the Payments (BoP, current US$) of Mozambique in 2008 to that in 2011?
Your response must be concise. 0.67. What is the ratio of the Payments (BoP, current US$) in Samoa in 2008 to that in 2011?
Offer a very short reply. 0.87. What is the ratio of the Payments (BoP, current US$) in Burundi in 2009 to that in 2010?
Provide a short and direct response. 0.87. What is the ratio of the Payments (BoP, current US$) of Kosovo in 2009 to that in 2010?
Offer a terse response. 0.92. What is the ratio of the Payments (BoP, current US$) of Mozambique in 2009 to that in 2010?
Offer a very short reply. 0.93. What is the ratio of the Payments (BoP, current US$) of Samoa in 2009 to that in 2010?
Your answer should be very brief. 0.83. What is the ratio of the Payments (BoP, current US$) of Burundi in 2009 to that in 2011?
Offer a terse response. 0.68. What is the ratio of the Payments (BoP, current US$) of Kosovo in 2009 to that in 2011?
Your answer should be compact. 0.77. What is the ratio of the Payments (BoP, current US$) in Mozambique in 2009 to that in 2011?
Ensure brevity in your answer.  0.62. What is the ratio of the Payments (BoP, current US$) in Samoa in 2009 to that in 2011?
Your response must be concise. 0.74. What is the ratio of the Payments (BoP, current US$) of Burundi in 2010 to that in 2011?
Your answer should be compact. 0.78. What is the ratio of the Payments (BoP, current US$) in Kosovo in 2010 to that in 2011?
Offer a very short reply. 0.84. What is the ratio of the Payments (BoP, current US$) of Mozambique in 2010 to that in 2011?
Your response must be concise. 0.66. What is the ratio of the Payments (BoP, current US$) in Samoa in 2010 to that in 2011?
Make the answer very short. 0.89. What is the difference between the highest and the second highest Payments (BoP, current US$) of Burundi?
Give a very brief answer. 1.72e+08. What is the difference between the highest and the second highest Payments (BoP, current US$) of Kosovo?
Provide a succinct answer. 6.41e+08. What is the difference between the highest and the second highest Payments (BoP, current US$) in Mozambique?
Your answer should be compact. 2.57e+09. What is the difference between the highest and the second highest Payments (BoP, current US$) of Samoa?
Offer a terse response. 4.78e+07. What is the difference between the highest and the lowest Payments (BoP, current US$) of Burundi?
Give a very brief answer. 3.39e+08. What is the difference between the highest and the lowest Payments (BoP, current US$) in Kosovo?
Your answer should be compact. 2.03e+09. What is the difference between the highest and the lowest Payments (BoP, current US$) of Mozambique?
Your answer should be compact. 3.70e+09. What is the difference between the highest and the lowest Payments (BoP, current US$) in Samoa?
Make the answer very short. 1.14e+08. 